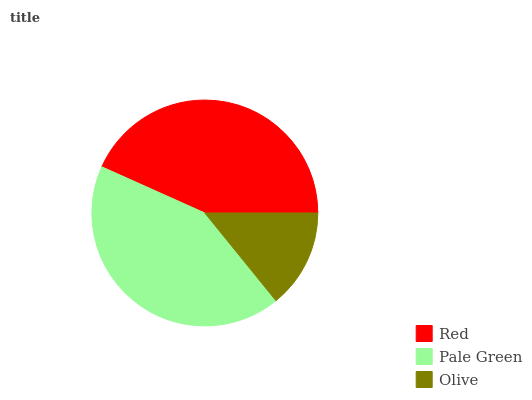Is Olive the minimum?
Answer yes or no. Yes. Is Red the maximum?
Answer yes or no. Yes. Is Pale Green the minimum?
Answer yes or no. No. Is Pale Green the maximum?
Answer yes or no. No. Is Red greater than Pale Green?
Answer yes or no. Yes. Is Pale Green less than Red?
Answer yes or no. Yes. Is Pale Green greater than Red?
Answer yes or no. No. Is Red less than Pale Green?
Answer yes or no. No. Is Pale Green the high median?
Answer yes or no. Yes. Is Pale Green the low median?
Answer yes or no. Yes. Is Red the high median?
Answer yes or no. No. Is Olive the low median?
Answer yes or no. No. 